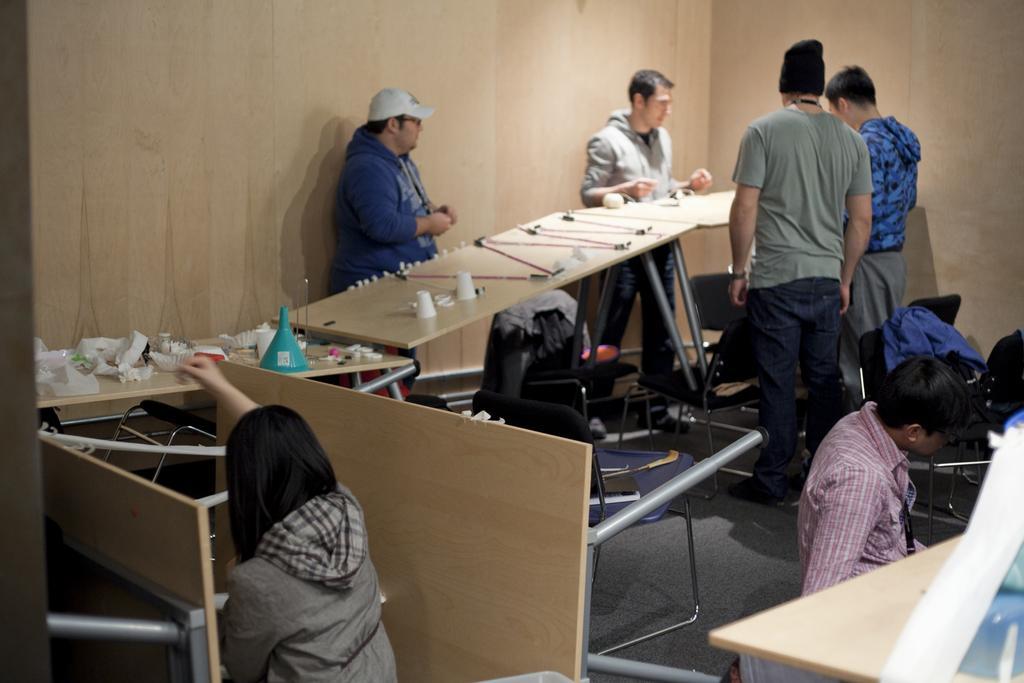How would you summarize this image in a sentence or two? The picture is taken in a closed room and at the right corner three people are standing and in front of them there is a table with some instruments placed on it and there are chairs, bags are placed on the floor and in the middle one man is wearing a blue dress and cap and behind them there is a wall and in the left corner one woman is sitting in front of the table and in the right corner another man is sitting on the chair in pink shirt, beside him there are chairs. 